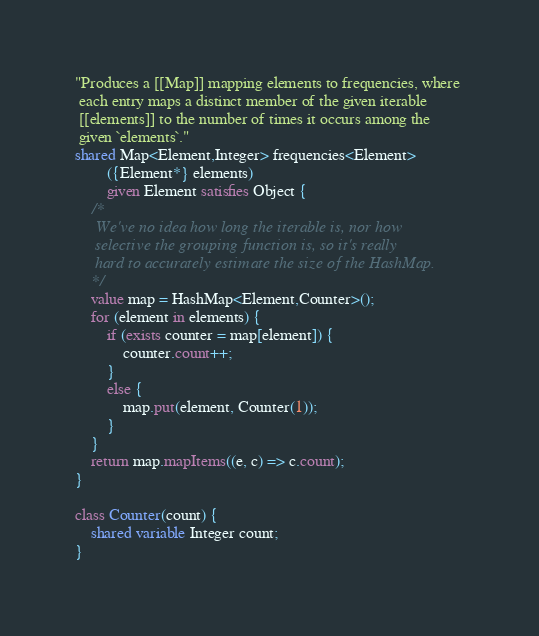Convert code to text. <code><loc_0><loc_0><loc_500><loc_500><_Ceylon_>"Produces a [[Map]] mapping elements to frequencies, where 
 each entry maps a distinct member of the given iterable
 [[elements]] to the number of times it occurs among the 
 given `elements`."
shared Map<Element,Integer> frequencies<Element>
        ({Element*} elements)
        given Element satisfies Object {
    /*
     We've no idea how long the iterable is, nor how 
     selective the grouping function is, so it's really 
     hard to accurately estimate the size of the HashMap.
    */
    value map = HashMap<Element,Counter>();
    for (element in elements) {
        if (exists counter = map[element]) {
            counter.count++;
        }
        else {
            map.put(element, Counter(1));
        }
    }
    return map.mapItems((e, c) => c.count);
}

class Counter(count) {
    shared variable Integer count;
}
</code> 